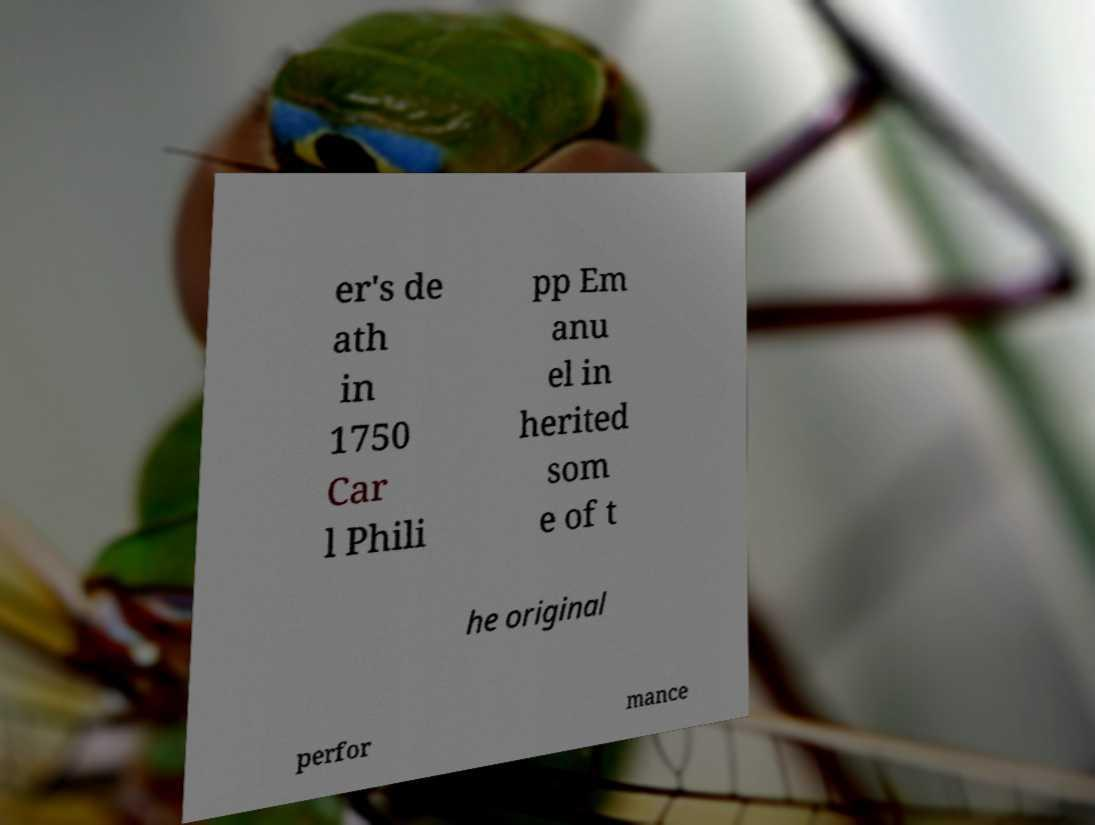What messages or text are displayed in this image? I need them in a readable, typed format. er's de ath in 1750 Car l Phili pp Em anu el in herited som e of t he original perfor mance 